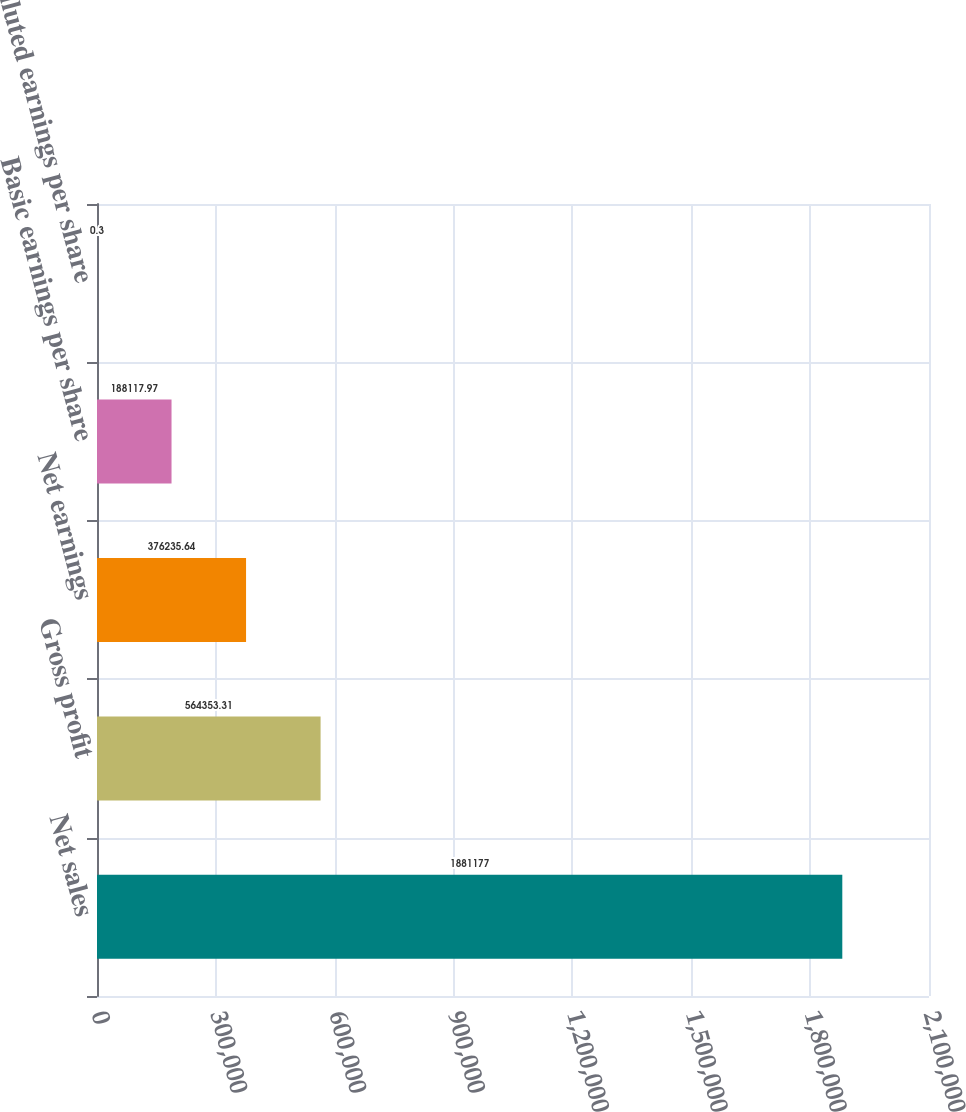<chart> <loc_0><loc_0><loc_500><loc_500><bar_chart><fcel>Net sales<fcel>Gross profit<fcel>Net earnings<fcel>Basic earnings per share<fcel>Diluted earnings per share<nl><fcel>1.88118e+06<fcel>564353<fcel>376236<fcel>188118<fcel>0.3<nl></chart> 